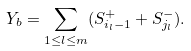Convert formula to latex. <formula><loc_0><loc_0><loc_500><loc_500>Y _ { b } = \sum _ { 1 \leq l \leq m } ( S _ { i _ { l } - 1 } ^ { + } + S _ { j _ { l } } ^ { - } ) .</formula> 